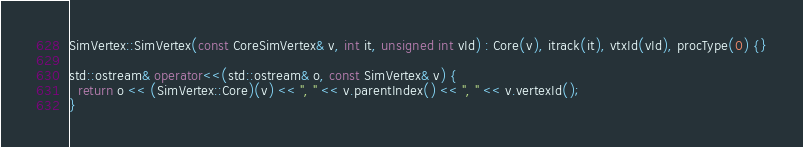Convert code to text. <code><loc_0><loc_0><loc_500><loc_500><_C++_>
SimVertex::SimVertex(const CoreSimVertex& v, int it, unsigned int vId) : Core(v), itrack(it), vtxId(vId), procType(0) {}

std::ostream& operator<<(std::ostream& o, const SimVertex& v) {
  return o << (SimVertex::Core)(v) << ", " << v.parentIndex() << ", " << v.vertexId();
}
</code> 